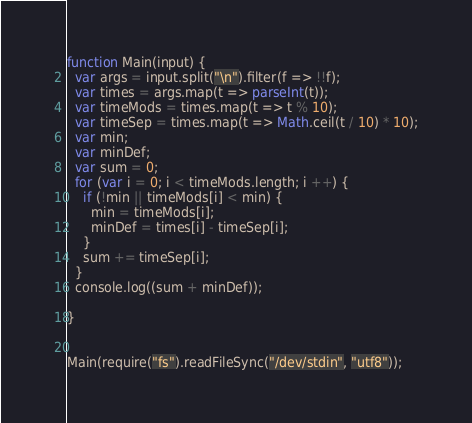Convert code to text. <code><loc_0><loc_0><loc_500><loc_500><_JavaScript_>function Main(input) {
  var args = input.split("\n").filter(f => !!f);
  var times = args.map(t => parseInt(t));
  var timeMods = times.map(t => t % 10);
  var timeSep = times.map(t => Math.ceil(t / 10) * 10);
  var min;
  var minDef;
  var sum = 0;
  for (var i = 0; i < timeMods.length; i ++) {
    if (!min || timeMods[i] < min) {
      min = timeMods[i];
      minDef = times[i] - timeSep[i];
    }
    sum += timeSep[i];
  }
  console.log((sum + minDef));

}


Main(require("fs").readFileSync("/dev/stdin", "utf8"));</code> 